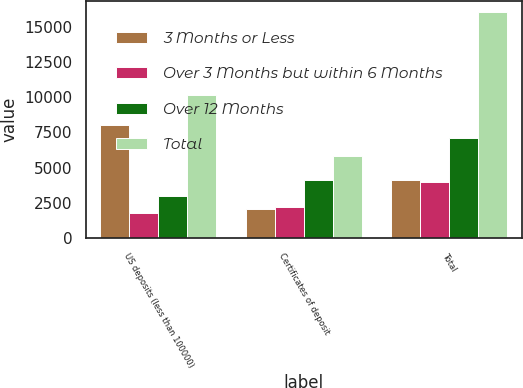<chart> <loc_0><loc_0><loc_500><loc_500><stacked_bar_chart><ecel><fcel>US deposits (less than 100000)<fcel>Certificates of deposit<fcel>Total<nl><fcel>3 Months or Less<fcel>8001<fcel>2059<fcel>4112<nl><fcel>Over 3 Months but within 6 Months<fcel>1737<fcel>2207<fcel>3944<nl><fcel>Over 12 Months<fcel>2976<fcel>4112<fcel>7088<nl><fcel>Total<fcel>10185<fcel>5844<fcel>16029<nl></chart> 